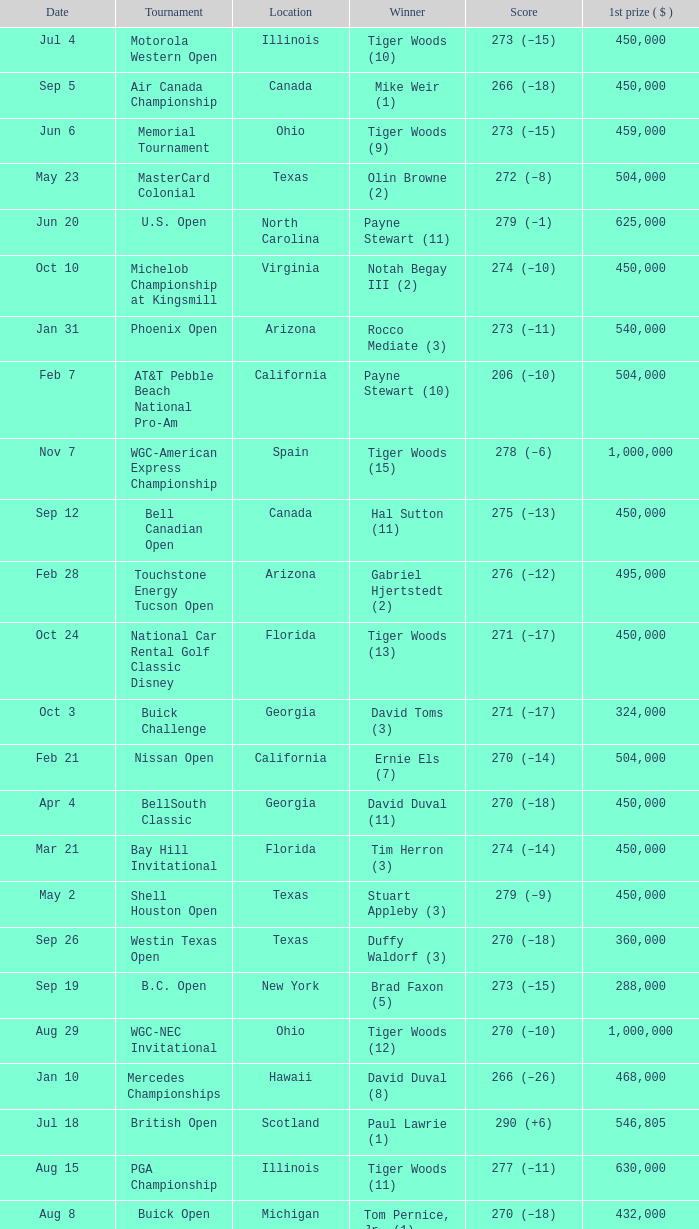What is the date of the Greater Greensboro Chrysler Classic? Apr 25. 